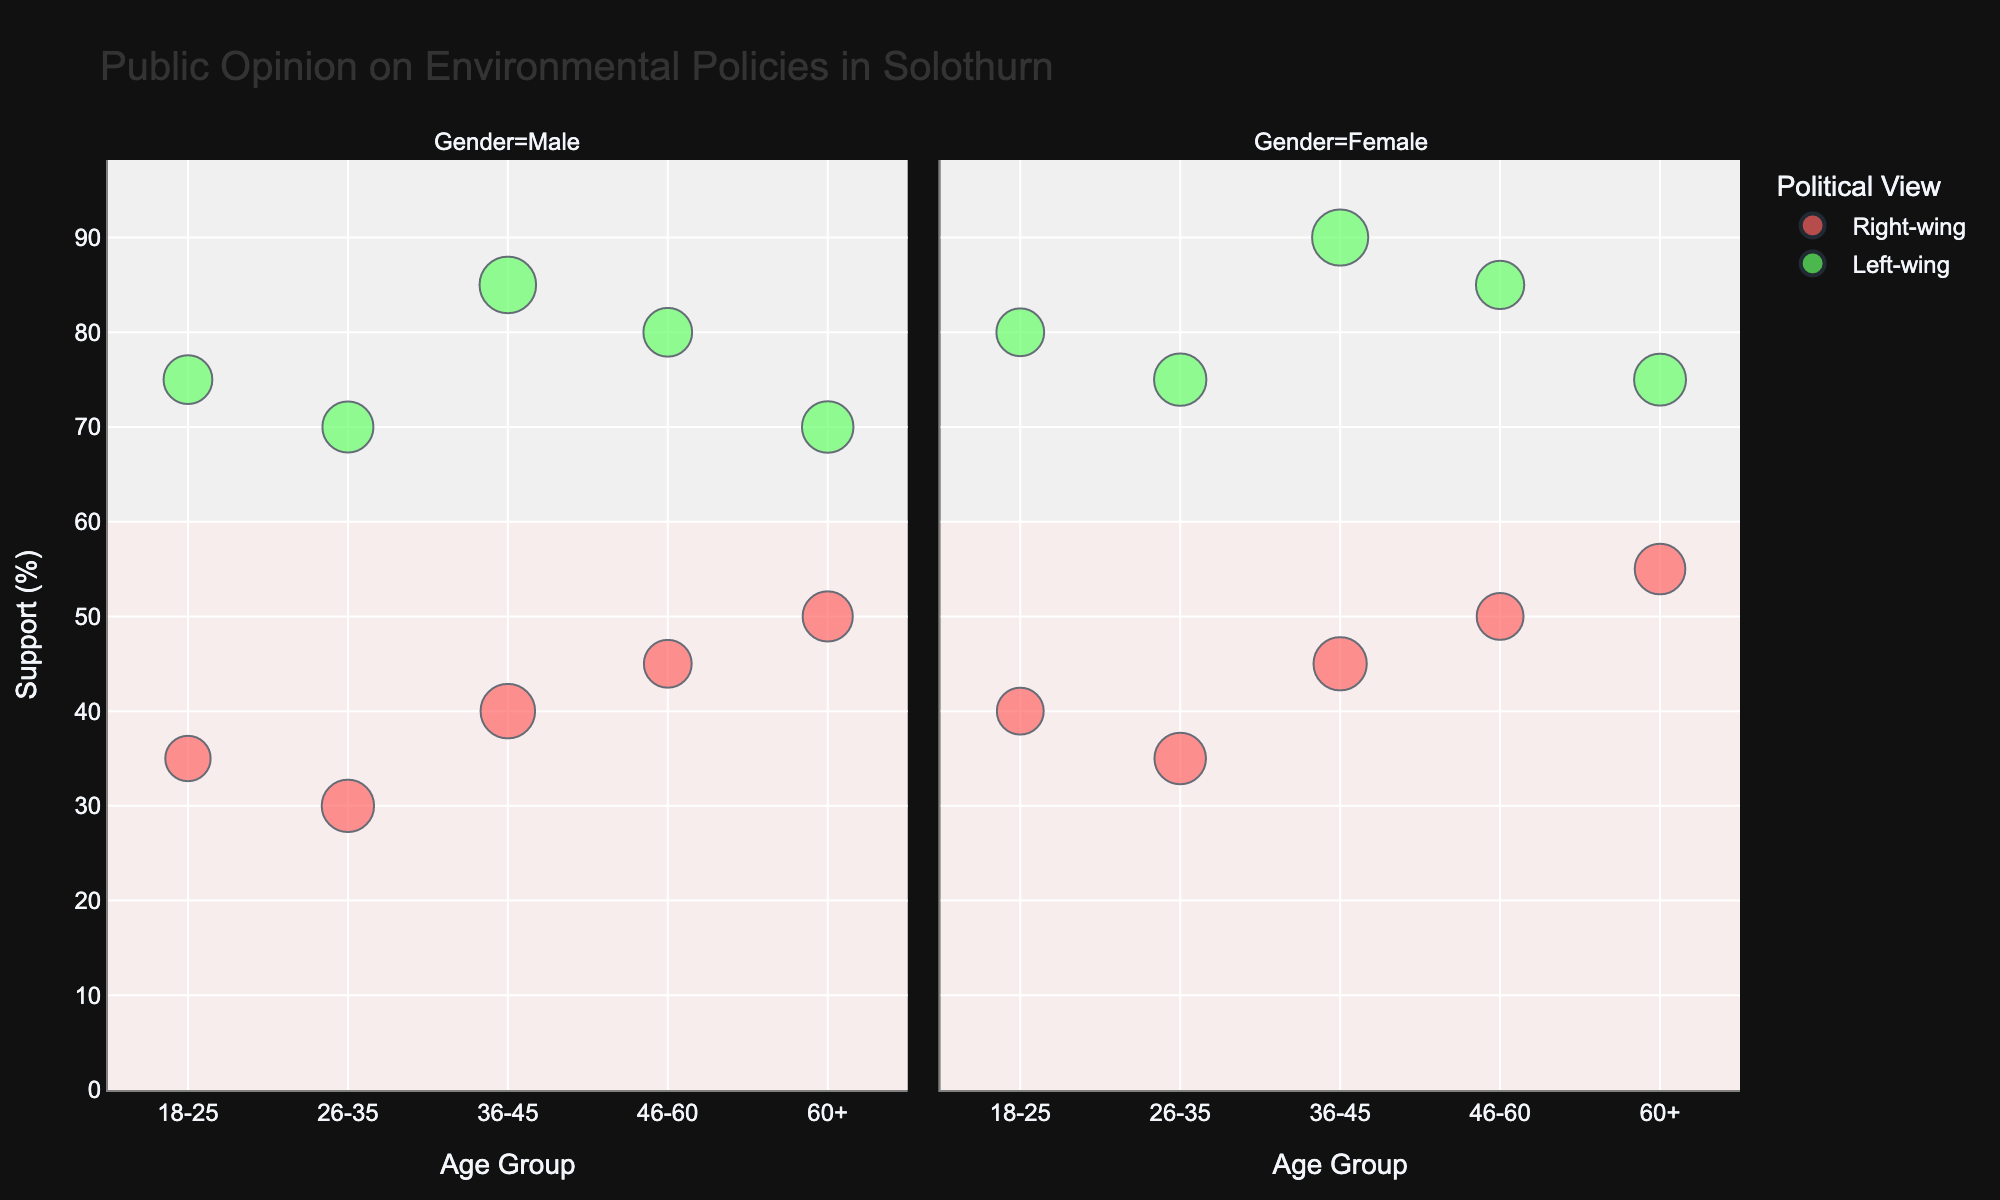What is the title of the figure? The title is usually placed at the top of the figure and is intended to give a brief description of what the figure illustrates. Here, the title reads "Public Opinion on Environmental Policies in Solothurn".
Answer: Public Opinion on Environmental Policies in Solothurn What political leaning has the highest support for environmental policies in the 36-45 age group? Look for the data points in the 36-45 age group and compare the support levels for both right-wing and left-wing. The left-wing has a higher support percentage.
Answer: Left-wing What is the size of the population that supports environmental policies the least? Find the data point with the lowest support for environmental policies and note its population size, which is the "26-35 Male Right-wing" group with 30% support.
Answer: 600 In the 46-60 age group, which gender has stronger support for environmental policies in the left-wing political leaning? Compare the support percentages for males and females in the 46-60 age group within the left-wing; females have stronger support at 85%.
Answer: Female How does support for environmental policies change from 18-25 age group to 60+ age group in the right-wing for males? Compare the support percentages for right-wing males in the 18-25 and 60+ age groups. Support increases from 35% to 50%.
Answer: Increases Which gender shows higher support for environmental policies in the 26-35 age group within the right-wing? Compare the support percentages between males and females in the 26-35 age group within the right-wing. Females show higher support at 35%.
Answer: Female What is the average support for environmental policies in the 36-45 age group for both genders combined? Add the support percentages for males and females in both political leanings in the 36-45 age group, then divide by the number of data points (4 in this case). (40 + 45 + 85 + 90) / 4 = 65%.
Answer: 65% How many data points represent left-wing females in all age groups? Each age group contains one data point for left-wing females. Count the total number of age groups, which is 5.
Answer: 5 Which age group of males has the largest population size in the left-wing? Look at the population sizes for left-wing males across all age groups and identify the largest one, which is the "36-45" age group with 700.
Answer: 36-45 What is the range of support for environmental policies among right-wing females across all age groups? Identify the highest and lowest support percentages among right-wing females. The highest is 55% (60+) and the lowest is 35% (26-35). Hence, the range is 55% - 35% = 20%.
Answer: 20% 